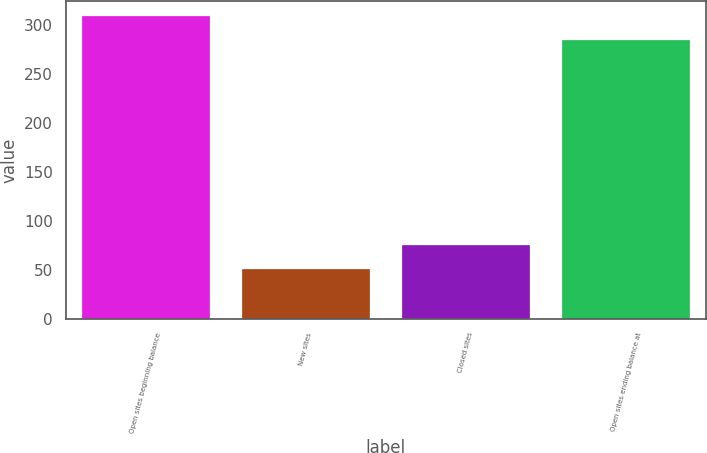Convert chart. <chart><loc_0><loc_0><loc_500><loc_500><bar_chart><fcel>Open sites beginning balance<fcel>New sites<fcel>Closed sites<fcel>Open sites ending balance at<nl><fcel>309.3<fcel>51<fcel>75.3<fcel>285<nl></chart> 